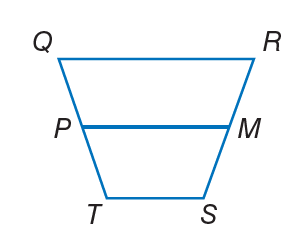Answer the mathemtical geometry problem and directly provide the correct option letter.
Question: For trapezoid Q R S T, M and P are midpoints of the legs. If Q R = 16, P M = 12, and T S = 4 x, find x.
Choices: A: 2 B: 8 C: 12 D: 16 A 